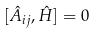<formula> <loc_0><loc_0><loc_500><loc_500>[ \hat { A } _ { i j } , \hat { H } ] = 0</formula> 